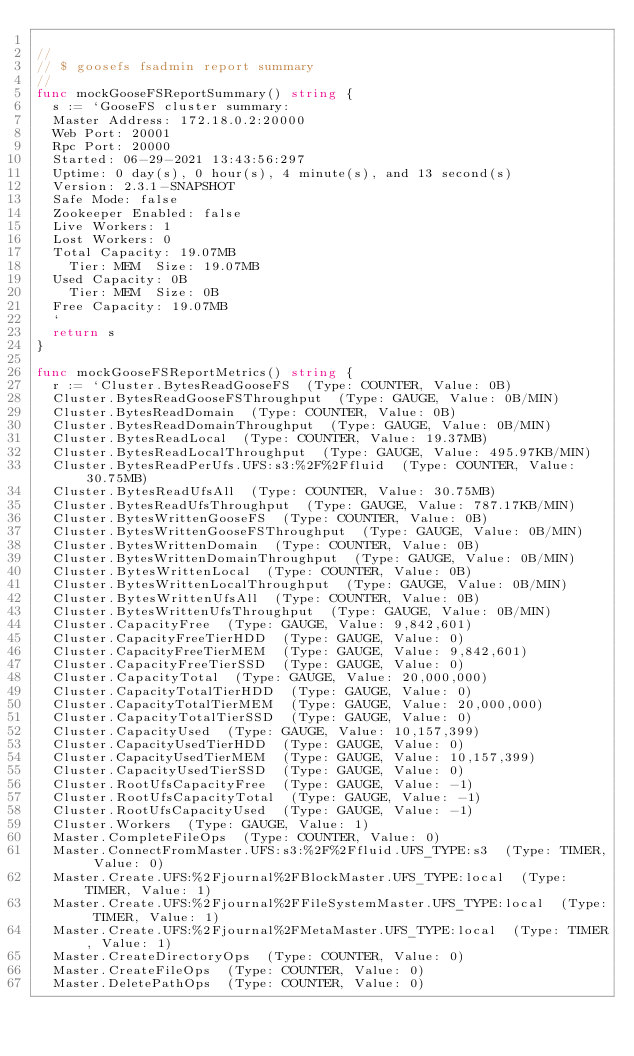<code> <loc_0><loc_0><loc_500><loc_500><_Go_>
//
// $ goosefs fsadmin report summary
//
func mockGooseFSReportSummary() string {
	s := `GooseFS cluster summary: 
	Master Address: 172.18.0.2:20000
	Web Port: 20001
	Rpc Port: 20000
	Started: 06-29-2021 13:43:56:297
	Uptime: 0 day(s), 0 hour(s), 4 minute(s), and 13 second(s)
	Version: 2.3.1-SNAPSHOT
	Safe Mode: false
	Zookeeper Enabled: false
	Live Workers: 1
	Lost Workers: 0
	Total Capacity: 19.07MB
		Tier: MEM  Size: 19.07MB
	Used Capacity: 0B
		Tier: MEM  Size: 0B
	Free Capacity: 19.07MB
	`
	return s
}

func mockGooseFSReportMetrics() string {
	r := `Cluster.BytesReadGooseFS  (Type: COUNTER, Value: 0B)
	Cluster.BytesReadGooseFSThroughput  (Type: GAUGE, Value: 0B/MIN)
	Cluster.BytesReadDomain  (Type: COUNTER, Value: 0B)
	Cluster.BytesReadDomainThroughput  (Type: GAUGE, Value: 0B/MIN)
	Cluster.BytesReadLocal  (Type: COUNTER, Value: 19.37MB)
	Cluster.BytesReadLocalThroughput  (Type: GAUGE, Value: 495.97KB/MIN)
	Cluster.BytesReadPerUfs.UFS:s3:%2F%2Ffluid  (Type: COUNTER, Value: 30.75MB)
	Cluster.BytesReadUfsAll  (Type: COUNTER, Value: 30.75MB)
	Cluster.BytesReadUfsThroughput  (Type: GAUGE, Value: 787.17KB/MIN)
	Cluster.BytesWrittenGooseFS  (Type: COUNTER, Value: 0B)
	Cluster.BytesWrittenGooseFSThroughput  (Type: GAUGE, Value: 0B/MIN)
	Cluster.BytesWrittenDomain  (Type: COUNTER, Value: 0B)
	Cluster.BytesWrittenDomainThroughput  (Type: GAUGE, Value: 0B/MIN)
	Cluster.BytesWrittenLocal  (Type: COUNTER, Value: 0B)
	Cluster.BytesWrittenLocalThroughput  (Type: GAUGE, Value: 0B/MIN)
	Cluster.BytesWrittenUfsAll  (Type: COUNTER, Value: 0B)
	Cluster.BytesWrittenUfsThroughput  (Type: GAUGE, Value: 0B/MIN)
	Cluster.CapacityFree  (Type: GAUGE, Value: 9,842,601)
	Cluster.CapacityFreeTierHDD  (Type: GAUGE, Value: 0)
	Cluster.CapacityFreeTierMEM  (Type: GAUGE, Value: 9,842,601)
	Cluster.CapacityFreeTierSSD  (Type: GAUGE, Value: 0)
	Cluster.CapacityTotal  (Type: GAUGE, Value: 20,000,000)
	Cluster.CapacityTotalTierHDD  (Type: GAUGE, Value: 0)
	Cluster.CapacityTotalTierMEM  (Type: GAUGE, Value: 20,000,000)
	Cluster.CapacityTotalTierSSD  (Type: GAUGE, Value: 0)
	Cluster.CapacityUsed  (Type: GAUGE, Value: 10,157,399)
	Cluster.CapacityUsedTierHDD  (Type: GAUGE, Value: 0)
	Cluster.CapacityUsedTierMEM  (Type: GAUGE, Value: 10,157,399)
	Cluster.CapacityUsedTierSSD  (Type: GAUGE, Value: 0)
	Cluster.RootUfsCapacityFree  (Type: GAUGE, Value: -1)
	Cluster.RootUfsCapacityTotal  (Type: GAUGE, Value: -1)
	Cluster.RootUfsCapacityUsed  (Type: GAUGE, Value: -1)
	Cluster.Workers  (Type: GAUGE, Value: 1)
	Master.CompleteFileOps  (Type: COUNTER, Value: 0)
	Master.ConnectFromMaster.UFS:s3:%2F%2Ffluid.UFS_TYPE:s3  (Type: TIMER, Value: 0)
	Master.Create.UFS:%2Fjournal%2FBlockMaster.UFS_TYPE:local  (Type: TIMER, Value: 1)
	Master.Create.UFS:%2Fjournal%2FFileSystemMaster.UFS_TYPE:local  (Type: TIMER, Value: 1)
	Master.Create.UFS:%2Fjournal%2FMetaMaster.UFS_TYPE:local  (Type: TIMER, Value: 1)
	Master.CreateDirectoryOps  (Type: COUNTER, Value: 0)
	Master.CreateFileOps  (Type: COUNTER, Value: 0)
	Master.DeletePathOps  (Type: COUNTER, Value: 0)</code> 